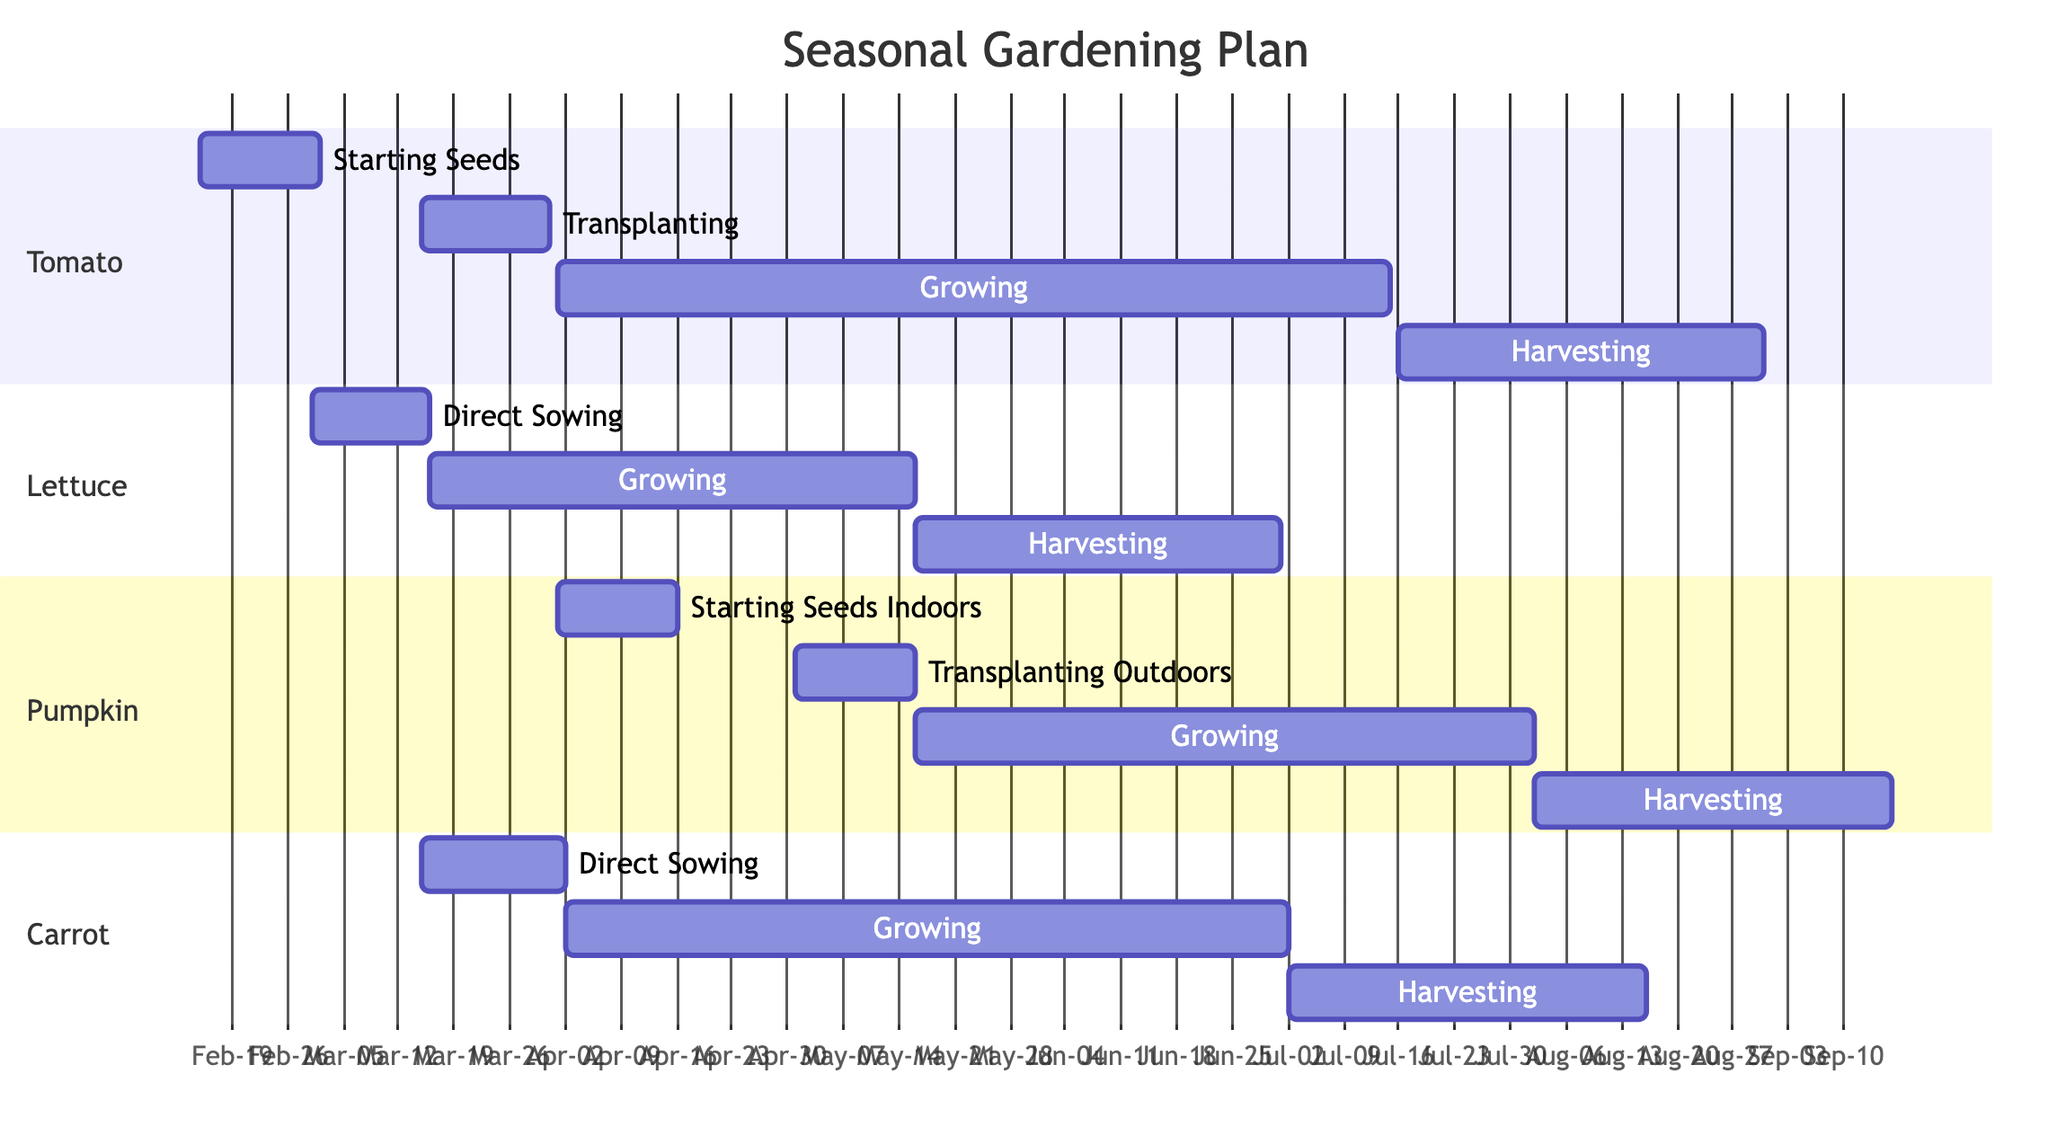What is the duration of the Tomato's growing phase? The growing phase for Tomato starts on April 1, 2023, and ends on July 15, 2023. To calculate the duration, we count the number of days between these two dates, which is 105 days.
Answer: 105 days What is the last date for harvesting Carrot? The harvesting phase for Carrot ends on August 15, 2023. This is directly stated in the harvesting phase timeline for Carrot.
Answer: August 15, 2023 Which plant has the longest harvesting phase? By examining the harvesting phases for each plant: Tomato (46 days), Lettuce (46 days), Pumpkin (45 days), and Carrot (45 days), it can be determined that Tomato and Lettuce have the longest harvesting phase at 46 days respectively.
Answer: Tomato and Lettuce When does the Lettuce growing phase start? From the diagram, the growing phase for Lettuce begins on March 16, 2023. This date is clearly marked in the corresponding phase for Lettuce.
Answer: March 16, 2023 How many distinct phases does Pumpkin have? The diagram indicates that Pumpkin has four distinct phases: Starting Seeds Indoors, Transplanting Outdoors, Growing, and Harvesting. Counting these phases gives a total of four.
Answer: 4 phases What overlaps between the growing phase of Tomato and the harvesting phase of Carrot? The growing phase of Tomato runs from April 1 to July 15, while the harvesting phase of Carrot runs from July 2 to August 15. The overlapping period is from July 2 to July 15, which is 14 days when both phases are active simultaneously.
Answer: 14 days What is the earliest starting phase among all plants? Analyzing the start dates, Tomato’s Starting Seeds phase begins on February 15, 2023, and Lettuce's Direct Sowing phase starts on March 1, 2023. Therefore, the earliest starting phase is for Tomato.
Answer: Starting Seeds Which plant begins its growing phase directly after the harvesting phase of Lettuce? The harvesting phase of Lettuce ends on June 30, 2023, and the growing phase for Pumpkin starts on May 16, but the next growing phase after Lettuce's harvesting is the Growing phase of Carrot on April 2, 2023, indicating that there's no immediate next phase since Carrot starts before the end of the harvesting phase of Lettuce.
Answer: None immediately after Are the harvesting phases for Pumpkin and Carrot consecutive? The harvesting phase for Pumpkin starts on August 2, 2023, which is immediately followed by the harvesting phase for Carrot starting on July 2, 2023. However, they are not consecutive as one phase ends before the other begins.
Answer: No, they are not consecutive 